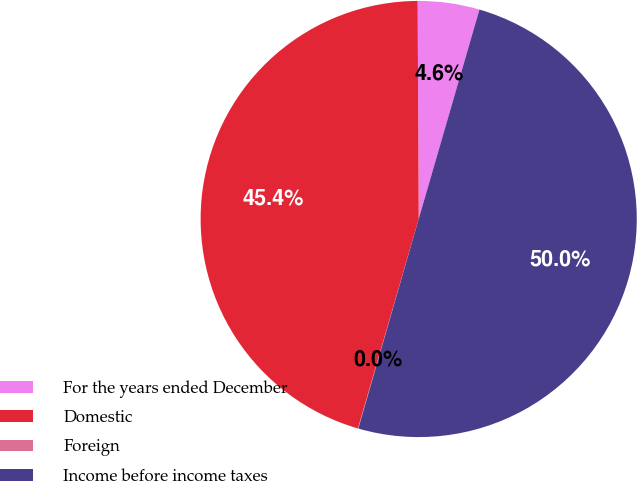Convert chart to OTSL. <chart><loc_0><loc_0><loc_500><loc_500><pie_chart><fcel>For the years ended December<fcel>Domestic<fcel>Foreign<fcel>Income before income taxes<nl><fcel>4.57%<fcel>45.43%<fcel>0.03%<fcel>49.97%<nl></chart> 